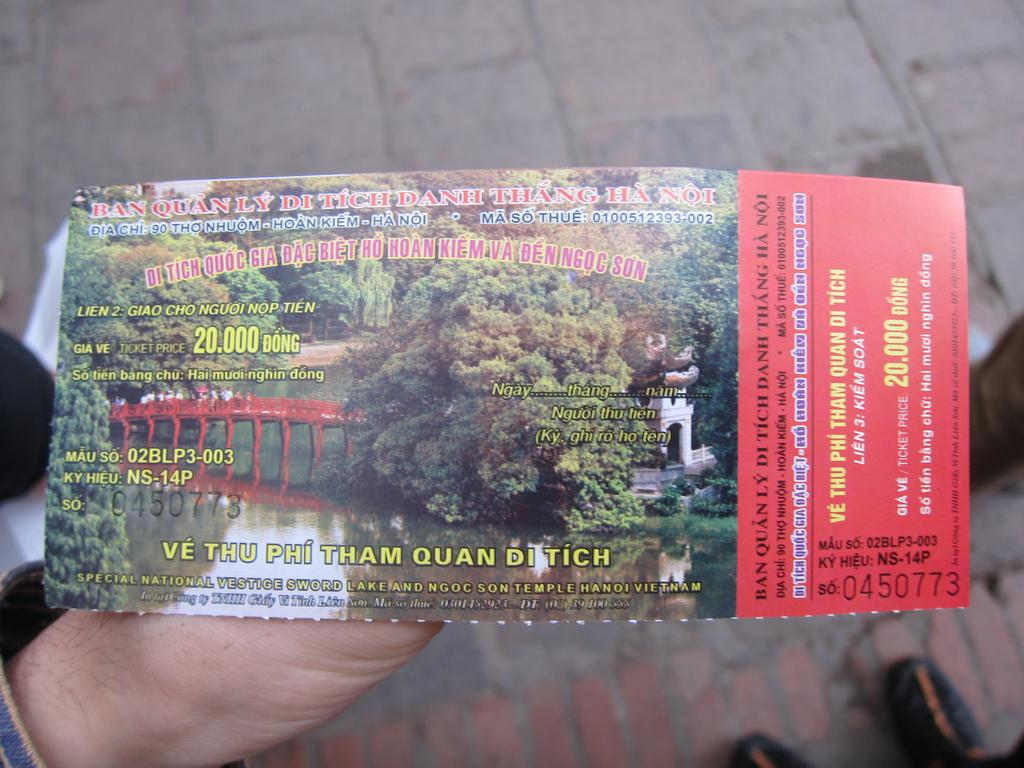<image>
Describe the image concisely. A ticket worth 20000 dong is held in someone's hand. 